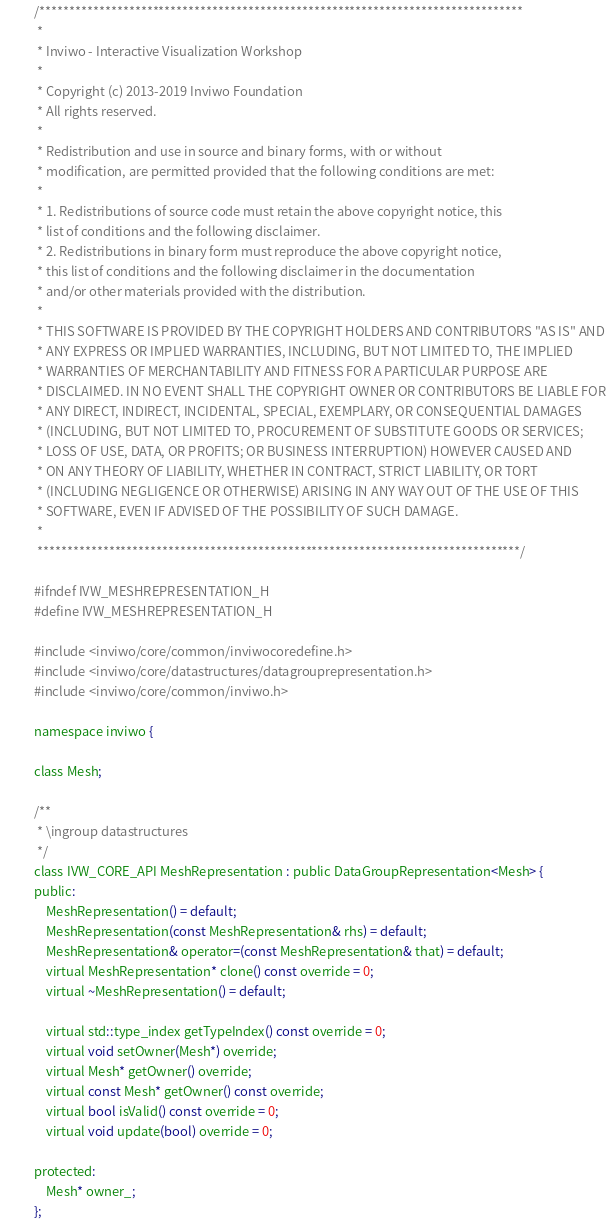Convert code to text. <code><loc_0><loc_0><loc_500><loc_500><_C_>/*********************************************************************************
 *
 * Inviwo - Interactive Visualization Workshop
 *
 * Copyright (c) 2013-2019 Inviwo Foundation
 * All rights reserved.
 *
 * Redistribution and use in source and binary forms, with or without
 * modification, are permitted provided that the following conditions are met:
 *
 * 1. Redistributions of source code must retain the above copyright notice, this
 * list of conditions and the following disclaimer.
 * 2. Redistributions in binary form must reproduce the above copyright notice,
 * this list of conditions and the following disclaimer in the documentation
 * and/or other materials provided with the distribution.
 *
 * THIS SOFTWARE IS PROVIDED BY THE COPYRIGHT HOLDERS AND CONTRIBUTORS "AS IS" AND
 * ANY EXPRESS OR IMPLIED WARRANTIES, INCLUDING, BUT NOT LIMITED TO, THE IMPLIED
 * WARRANTIES OF MERCHANTABILITY AND FITNESS FOR A PARTICULAR PURPOSE ARE
 * DISCLAIMED. IN NO EVENT SHALL THE COPYRIGHT OWNER OR CONTRIBUTORS BE LIABLE FOR
 * ANY DIRECT, INDIRECT, INCIDENTAL, SPECIAL, EXEMPLARY, OR CONSEQUENTIAL DAMAGES
 * (INCLUDING, BUT NOT LIMITED TO, PROCUREMENT OF SUBSTITUTE GOODS OR SERVICES;
 * LOSS OF USE, DATA, OR PROFITS; OR BUSINESS INTERRUPTION) HOWEVER CAUSED AND
 * ON ANY THEORY OF LIABILITY, WHETHER IN CONTRACT, STRICT LIABILITY, OR TORT
 * (INCLUDING NEGLIGENCE OR OTHERWISE) ARISING IN ANY WAY OUT OF THE USE OF THIS
 * SOFTWARE, EVEN IF ADVISED OF THE POSSIBILITY OF SUCH DAMAGE.
 *
 *********************************************************************************/

#ifndef IVW_MESHREPRESENTATION_H
#define IVW_MESHREPRESENTATION_H

#include <inviwo/core/common/inviwocoredefine.h>
#include <inviwo/core/datastructures/datagrouprepresentation.h>
#include <inviwo/core/common/inviwo.h>

namespace inviwo {

class Mesh;

/**
 * \ingroup datastructures
 */
class IVW_CORE_API MeshRepresentation : public DataGroupRepresentation<Mesh> {
public:
    MeshRepresentation() = default;
    MeshRepresentation(const MeshRepresentation& rhs) = default;
    MeshRepresentation& operator=(const MeshRepresentation& that) = default;
    virtual MeshRepresentation* clone() const override = 0;
    virtual ~MeshRepresentation() = default;

    virtual std::type_index getTypeIndex() const override = 0;
    virtual void setOwner(Mesh*) override;
    virtual Mesh* getOwner() override;
    virtual const Mesh* getOwner() const override;
    virtual bool isValid() const override = 0;
    virtual void update(bool) override = 0;

protected:
    Mesh* owner_;
};
</code> 